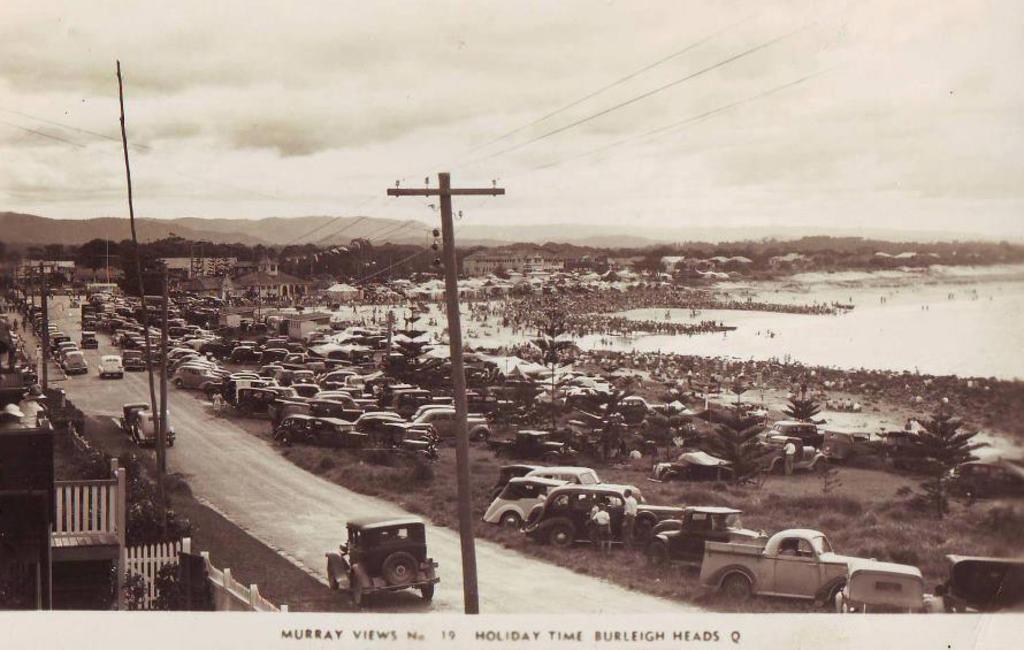Could you give a brief overview of what you see in this image? In this image there is an old photograph of a city, in the photograph there are cars passing on the road and a few cars parked and there are trees, electric poles with cables on it, houses, mountains and there is a lake, at the bottom of the image there is some text written. 